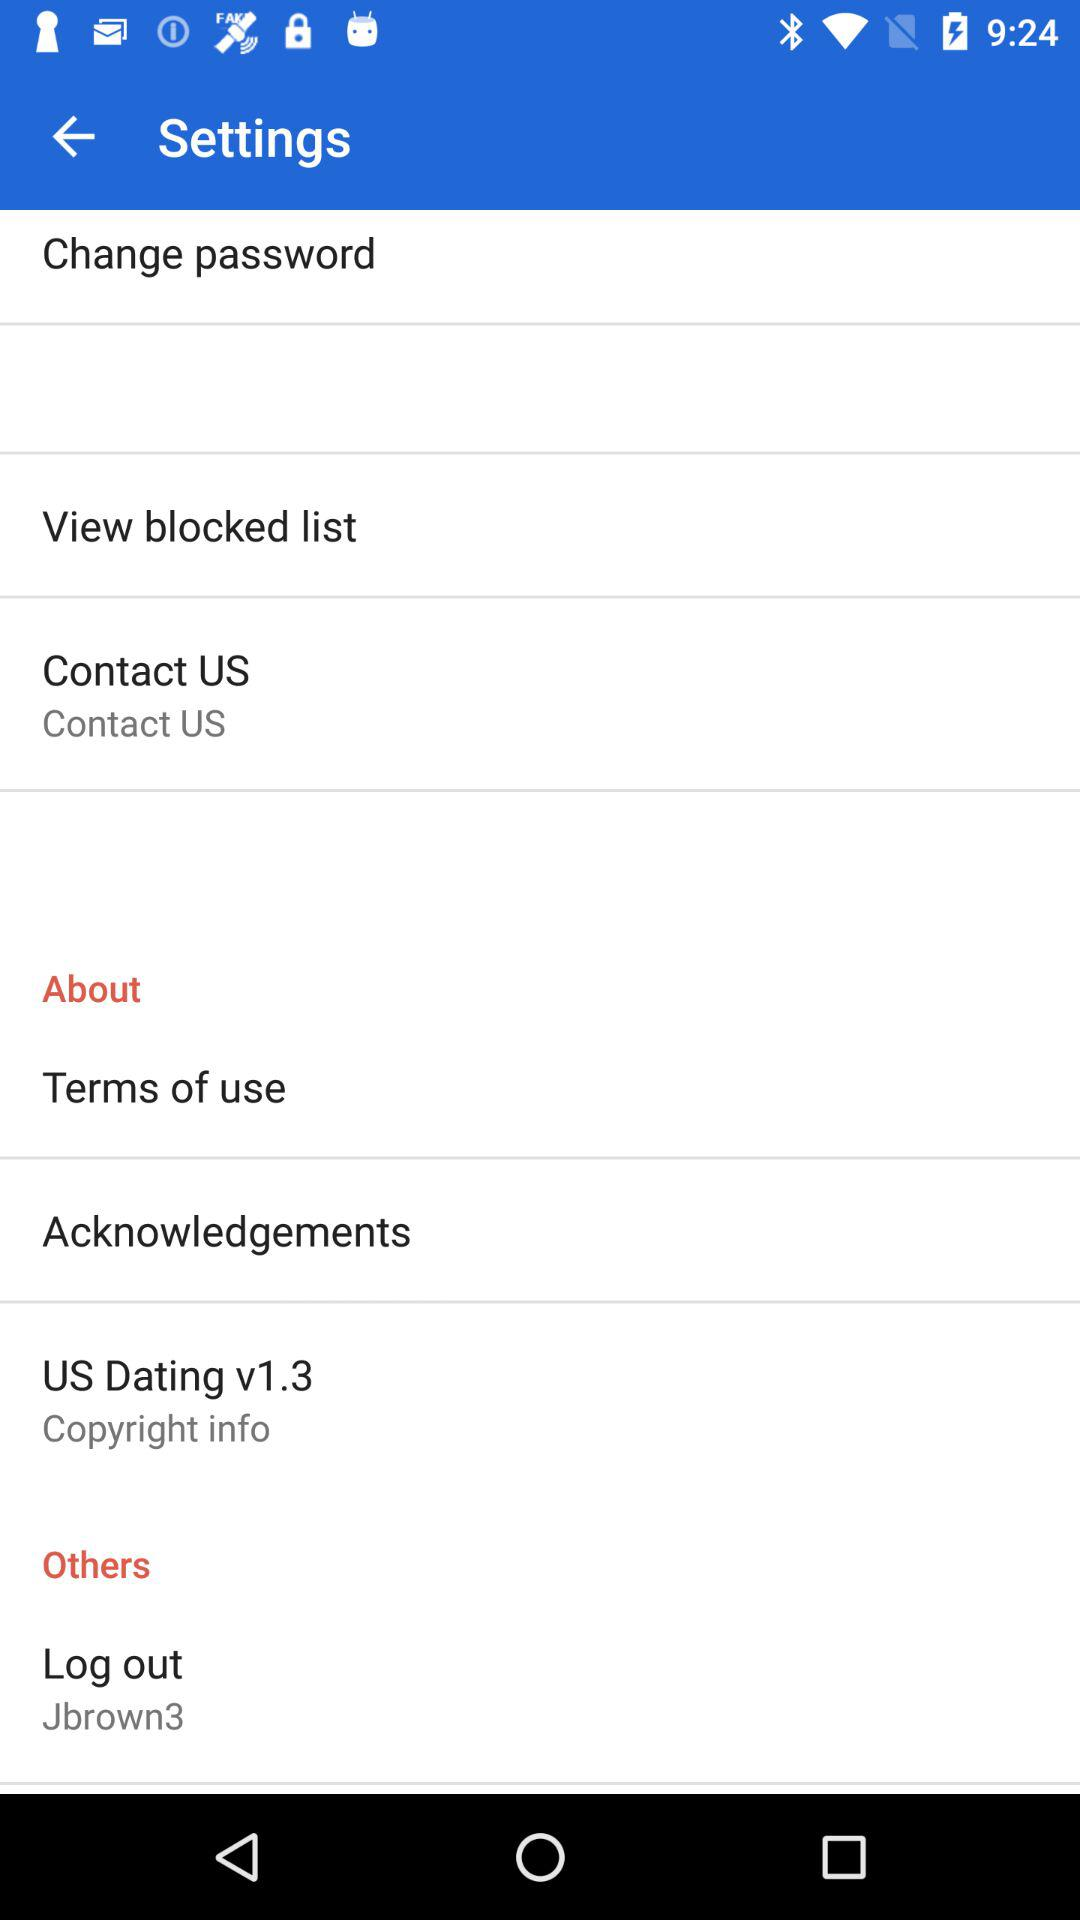Which version of the "US dating" application is used? The used version is v1.3. 